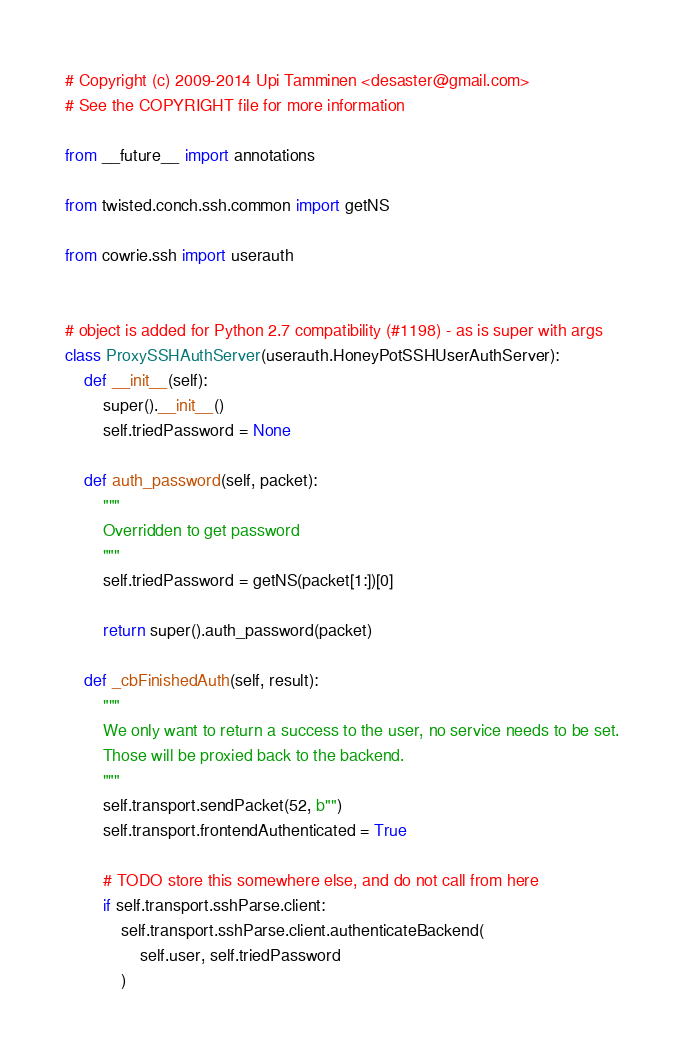Convert code to text. <code><loc_0><loc_0><loc_500><loc_500><_Python_># Copyright (c) 2009-2014 Upi Tamminen <desaster@gmail.com>
# See the COPYRIGHT file for more information

from __future__ import annotations

from twisted.conch.ssh.common import getNS

from cowrie.ssh import userauth


# object is added for Python 2.7 compatibility (#1198) - as is super with args
class ProxySSHAuthServer(userauth.HoneyPotSSHUserAuthServer):
    def __init__(self):
        super().__init__()
        self.triedPassword = None

    def auth_password(self, packet):
        """
        Overridden to get password
        """
        self.triedPassword = getNS(packet[1:])[0]

        return super().auth_password(packet)

    def _cbFinishedAuth(self, result):
        """
        We only want to return a success to the user, no service needs to be set.
        Those will be proxied back to the backend.
        """
        self.transport.sendPacket(52, b"")
        self.transport.frontendAuthenticated = True

        # TODO store this somewhere else, and do not call from here
        if self.transport.sshParse.client:
            self.transport.sshParse.client.authenticateBackend(
                self.user, self.triedPassword
            )
</code> 